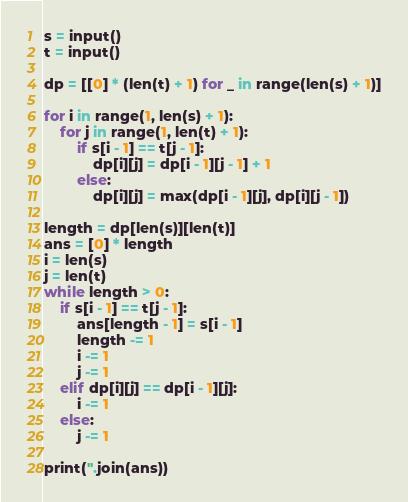<code> <loc_0><loc_0><loc_500><loc_500><_Python_>s = input()
t = input()

dp = [[0] * (len(t) + 1) for _ in range(len(s) + 1)]

for i in range(1, len(s) + 1):
    for j in range(1, len(t) + 1):
        if s[i - 1] == t[j - 1]:
            dp[i][j] = dp[i - 1][j - 1] + 1
        else:
            dp[i][j] = max(dp[i - 1][j], dp[i][j - 1])

length = dp[len(s)][len(t)]
ans = [0] * length
i = len(s)
j = len(t)
while length > 0:
    if s[i - 1] == t[j - 1]:
        ans[length - 1] = s[i - 1]
        length -= 1
        i -= 1
        j -= 1
    elif dp[i][j] == dp[i - 1][j]:
        i -= 1
    else:
        j -= 1

print(''.join(ans))
</code> 